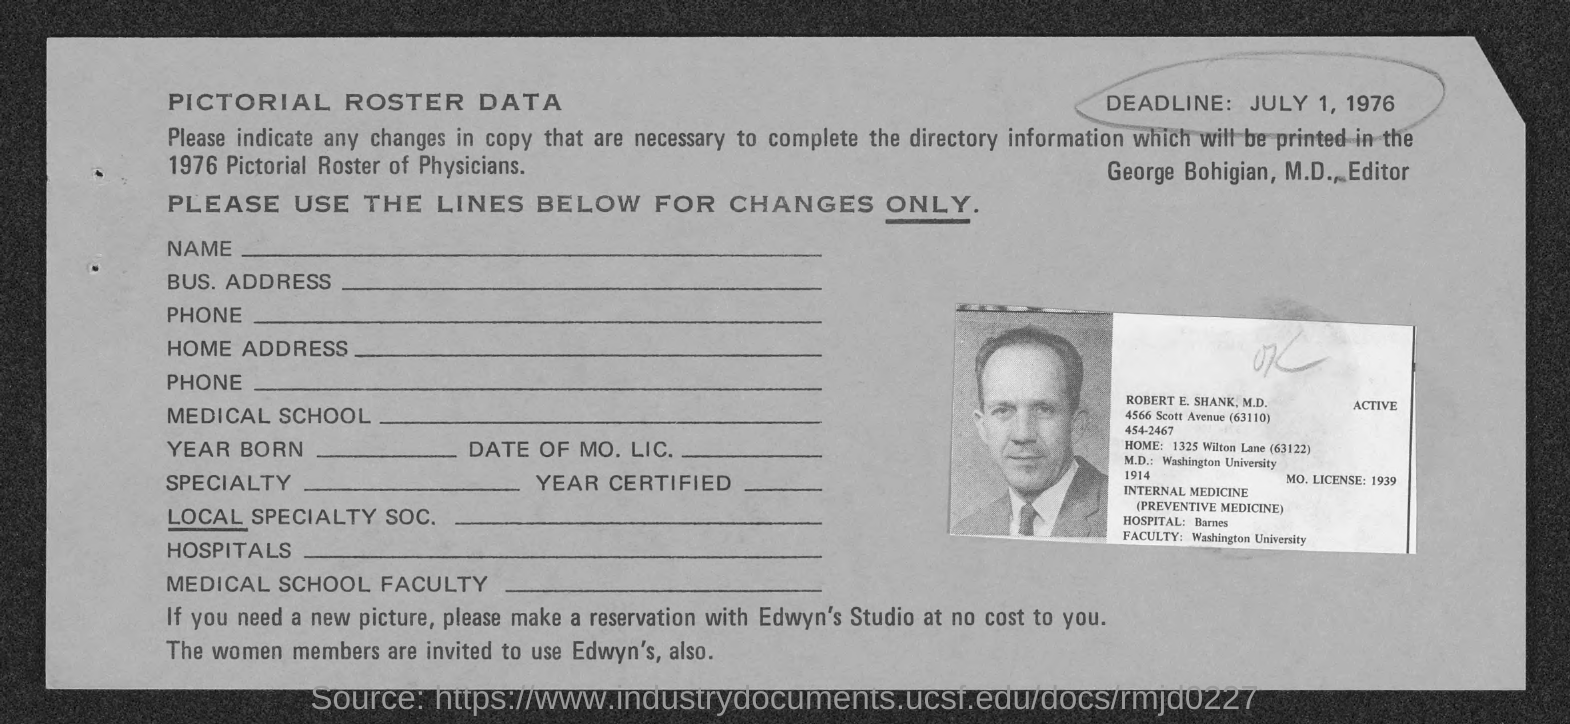Specify some key components in this picture. Robert E. Shank is a faculty member at Washington University. The home address of Robert E. Shank is located at 1325 Wilton Lane, which is located in the 63122 zip code. What is the license number?" "It is 1939... Robert E. Shank completed his M.D. from Washington University. The deadline is July 1, 1976. 